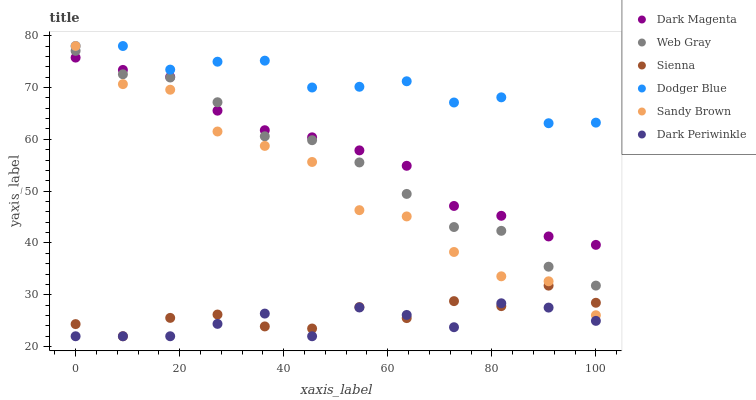Does Dark Periwinkle have the minimum area under the curve?
Answer yes or no. Yes. Does Dodger Blue have the maximum area under the curve?
Answer yes or no. Yes. Does Dark Magenta have the minimum area under the curve?
Answer yes or no. No. Does Dark Magenta have the maximum area under the curve?
Answer yes or no. No. Is Dark Magenta the smoothest?
Answer yes or no. Yes. Is Sandy Brown the roughest?
Answer yes or no. Yes. Is Sienna the smoothest?
Answer yes or no. No. Is Sienna the roughest?
Answer yes or no. No. Does Sienna have the lowest value?
Answer yes or no. Yes. Does Dark Magenta have the lowest value?
Answer yes or no. No. Does Sandy Brown have the highest value?
Answer yes or no. Yes. Does Dark Magenta have the highest value?
Answer yes or no. No. Is Dark Periwinkle less than Dark Magenta?
Answer yes or no. Yes. Is Web Gray greater than Sienna?
Answer yes or no. Yes. Does Web Gray intersect Sandy Brown?
Answer yes or no. Yes. Is Web Gray less than Sandy Brown?
Answer yes or no. No. Is Web Gray greater than Sandy Brown?
Answer yes or no. No. Does Dark Periwinkle intersect Dark Magenta?
Answer yes or no. No. 